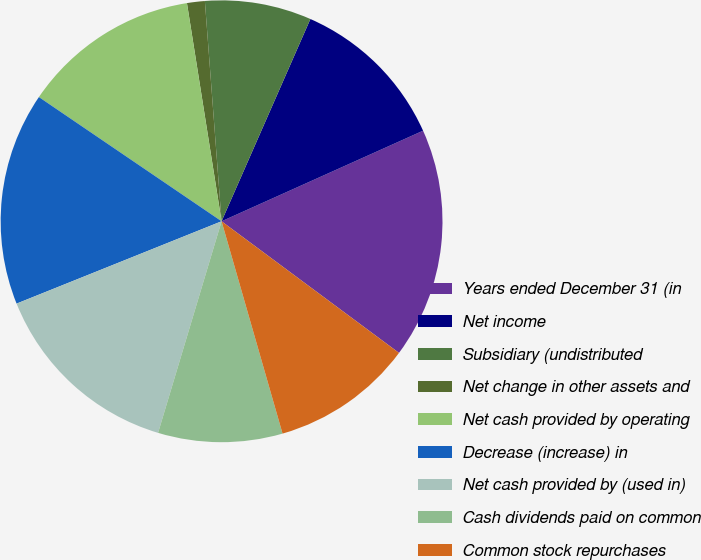Convert chart. <chart><loc_0><loc_0><loc_500><loc_500><pie_chart><fcel>Years ended December 31 (in<fcel>Net income<fcel>Subsidiary (undistributed<fcel>Net change in other assets and<fcel>Net cash provided by operating<fcel>Decrease (increase) in<fcel>Net cash provided by (used in)<fcel>Cash dividends paid on common<fcel>Common stock repurchases<fcel>Proceeds from stock options<nl><fcel>16.88%<fcel>11.69%<fcel>7.79%<fcel>1.3%<fcel>12.99%<fcel>15.58%<fcel>14.28%<fcel>9.09%<fcel>10.39%<fcel>0.0%<nl></chart> 